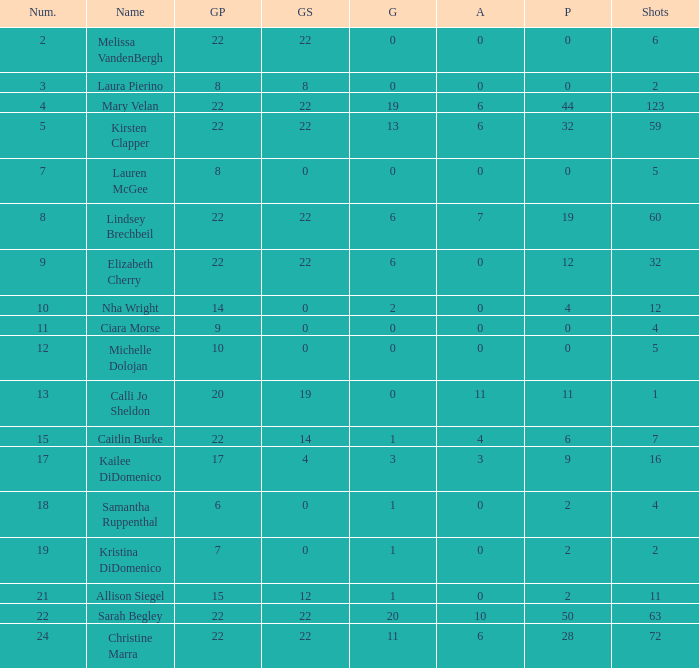How many numbers belong to the player with 10 assists?  1.0. 